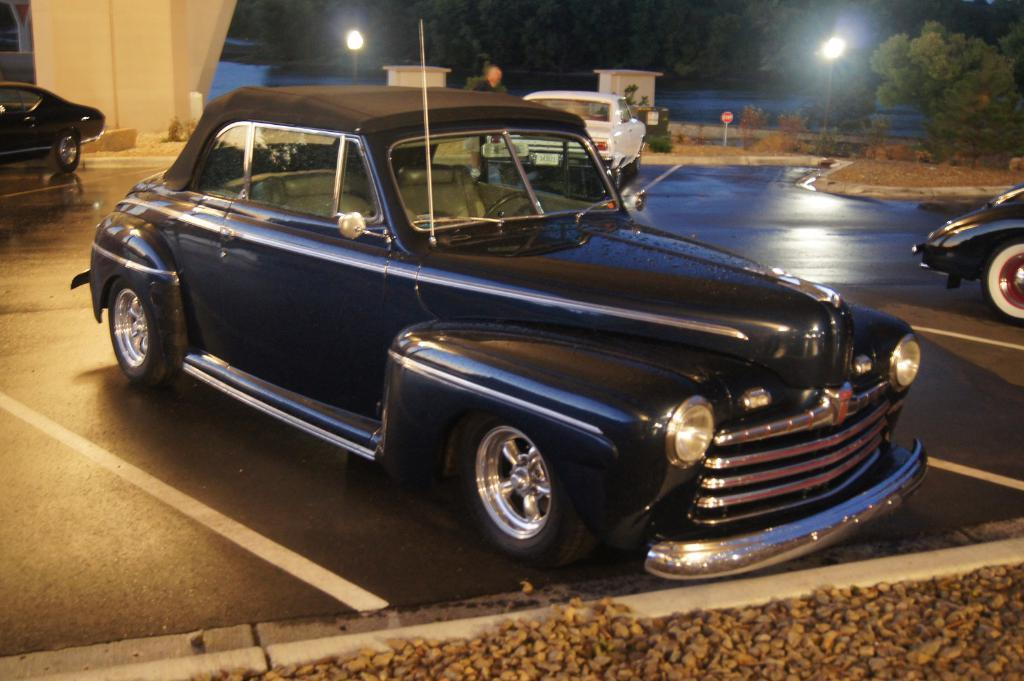What type of vehicles can be seen on the road in the image? There are cars on the road in the image. What other objects can be seen in the image besides the cars? There are stones, poles, lights, and trees visible in the image. What type of structures are the poles in the image? The poles in the image are likely utility poles or streetlights. What can be seen in the background of the image? There are trees in the background of the image. Is there a bear walking through the quicksand in the image? No, there is no bear or quicksand present in the image. 